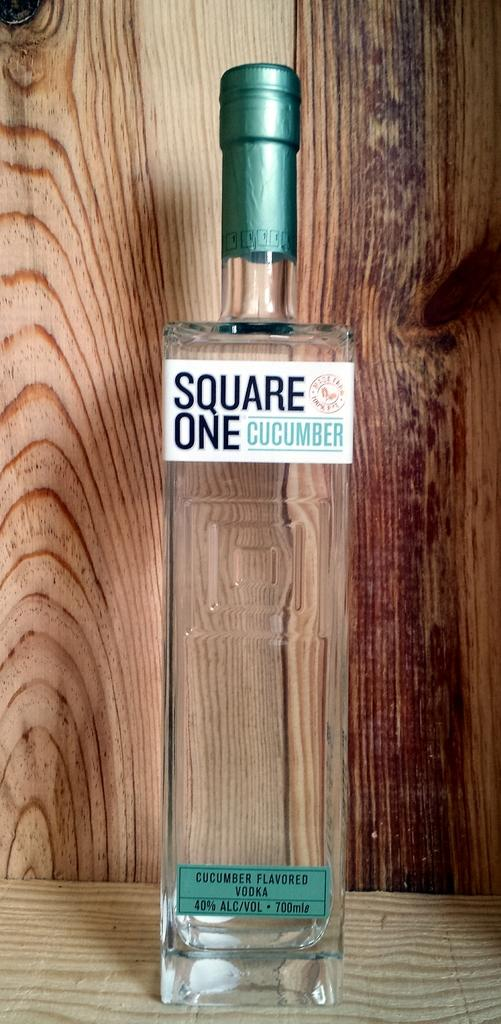Provide a one-sentence caption for the provided image. A rectangle bottle of cucumber vodka standing in a wooden presentation box. 